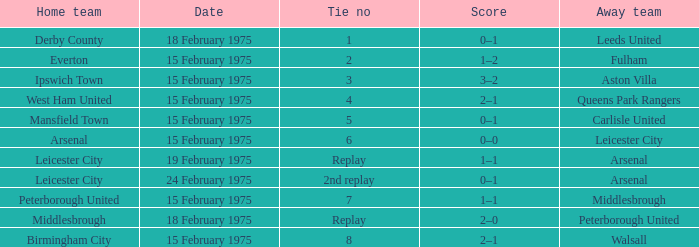What was the date when the away team was carlisle united? 15 February 1975. 